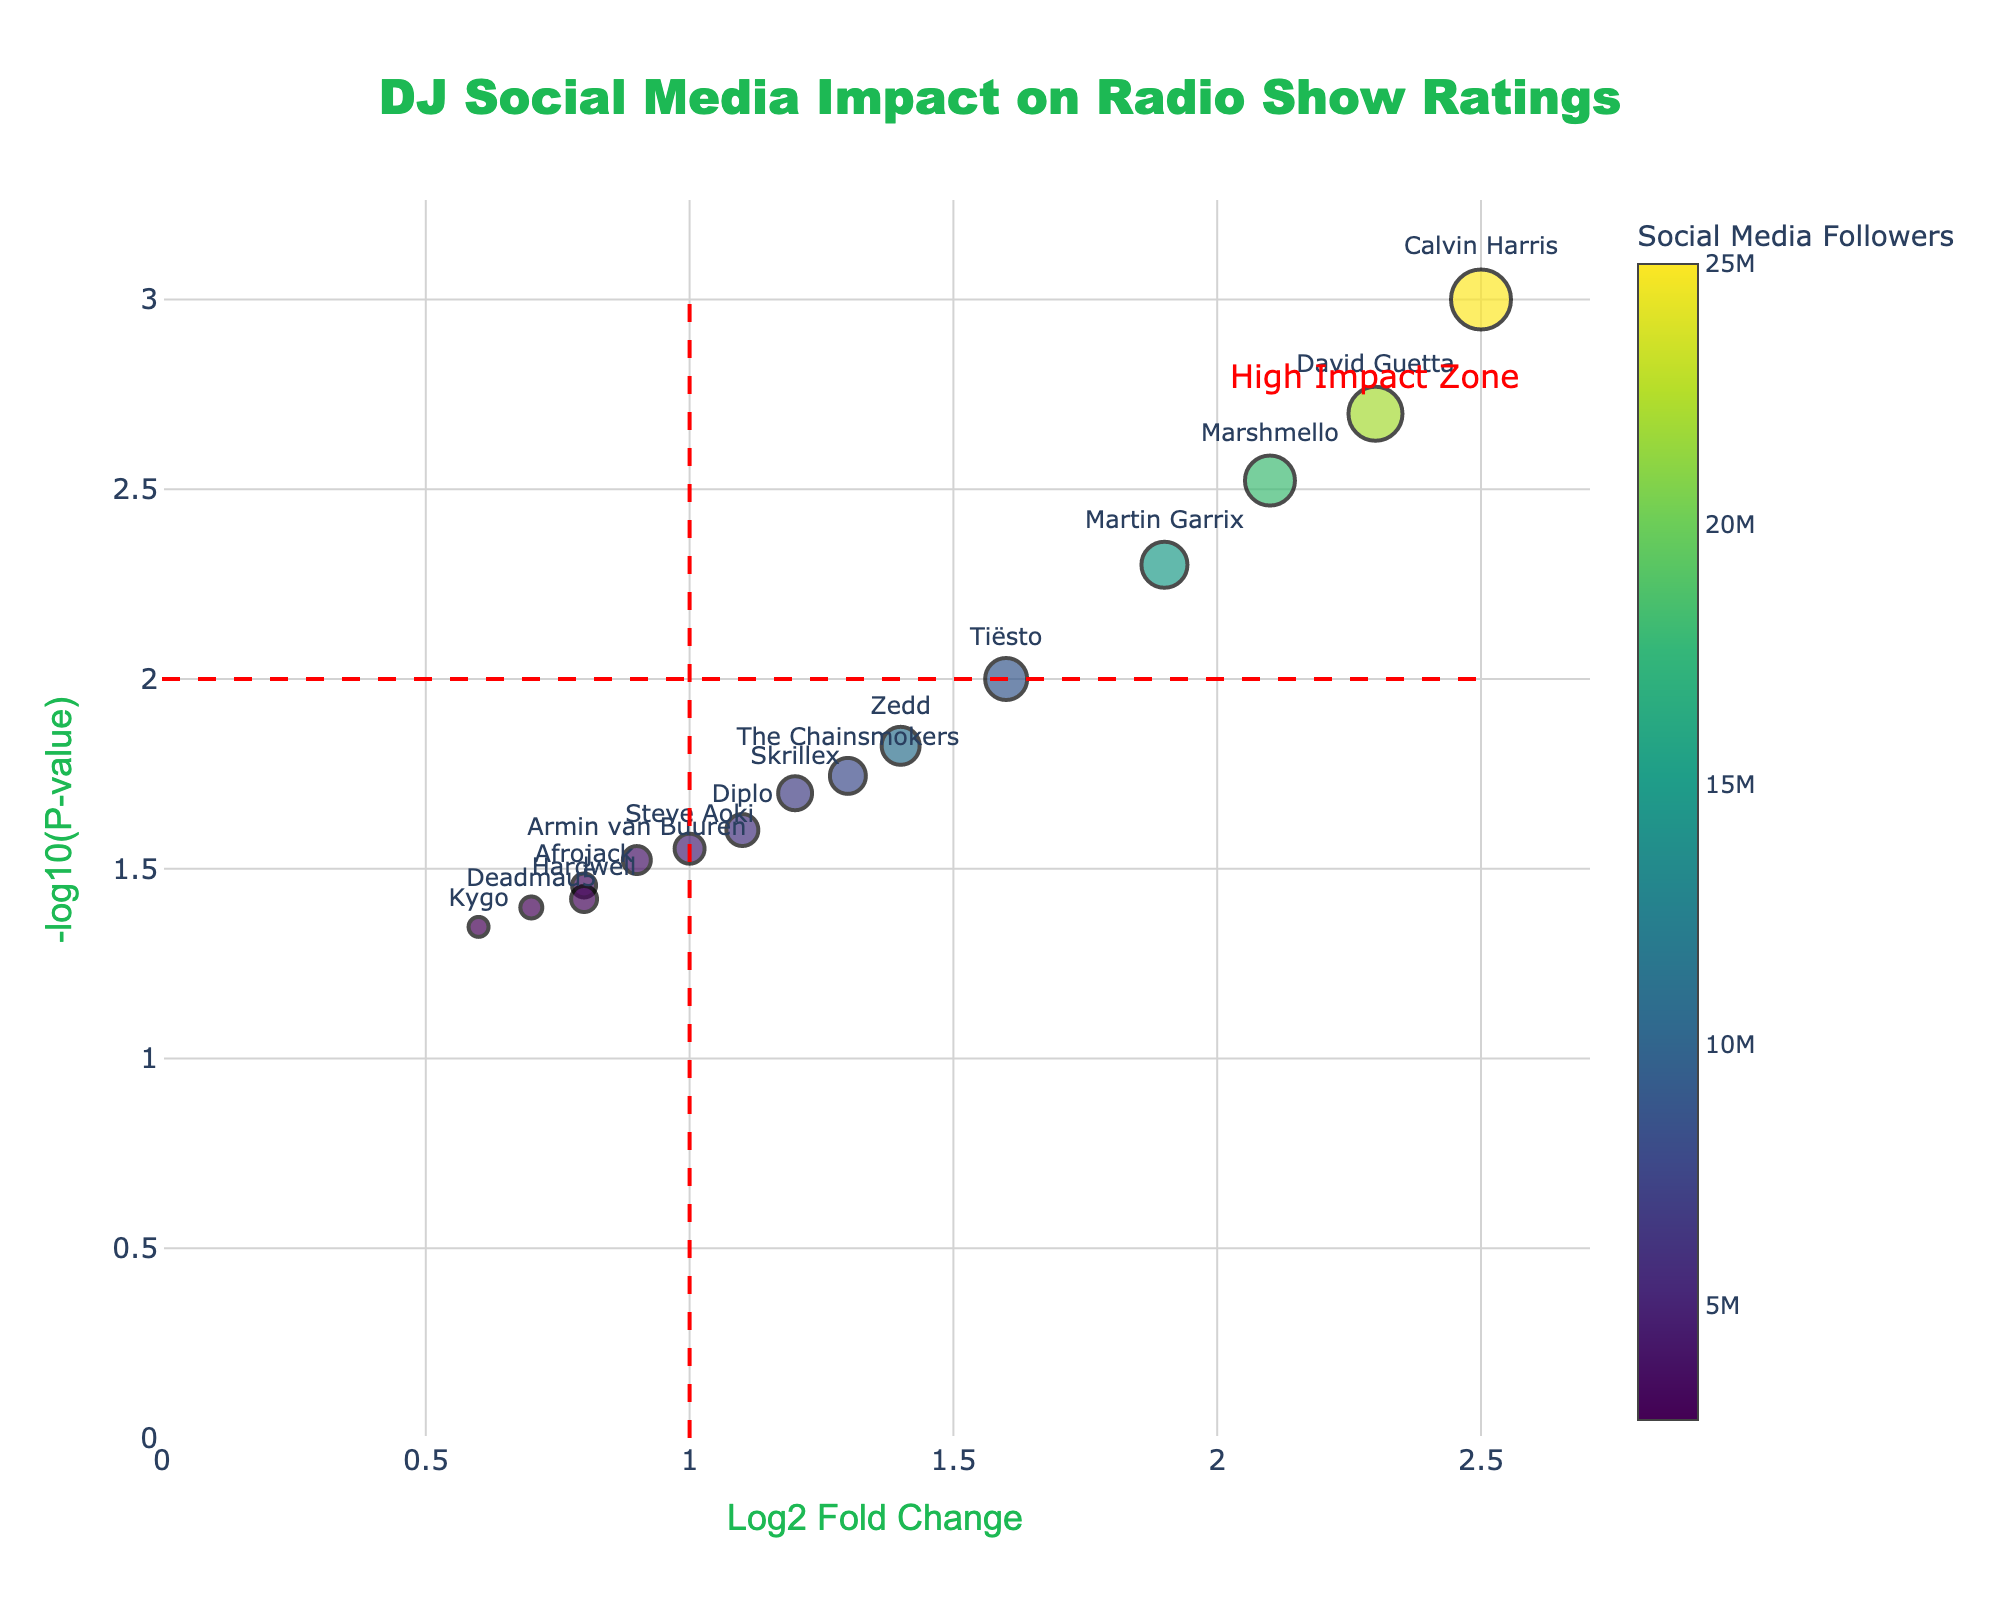How many DJs are displayed in the plot? To determine the number of DJs, count the number of markers or data points visible in the plot. Each marker represents a DJ.
Answer: 15 What is the title of the plot? The title can usually be found at the top of the plot. In this case, it explicitly mentions the plot's content.
Answer: DJ Social Media Impact on Radio Show Ratings Which DJ has the highest Log2 Fold Change (Log2FC)? Log2FC values are shown on the x-axis. By identifying the marker farthest to the right, you can determine the DJ with the highest Log2FC.
Answer: Calvin Harris How many DJs have a P-value less than 0.02? To find this, look for markers above the -log10(P-value) of -log10(0.02). Count these markers.
Answer: 6 Which DJ has the fewest social media followers, and what is their Radio Show Rating? To find the DJ with the fewest followers, look for the marker with the lowest color intensity or read the hover text for each DJ. Identify their corresponding Radio Show Rating from the hover text or marker size.
Answer: Deadmau5, 7.3 Which DJ is in the "High Impact Zone"? The "High Impact Zone" is marked by annotations or lines. Find the DJ within this region's boundaries, which is defined by a Log2FC greater than 2 and -log10(P-value) greater than 2.
Answer: Calvin Harris Compare the Radio Show Ratings between Marshmello and David Guetta. Who has a higher rating? Check the hover text or marker sizes for Marshmello and David Guetta, and compare their Radio Show Ratings.
Answer: Calvin Harris What’s the average Log2FC of DJs with a Radio Show Rating above 8.0? Identify the DJs with Radio Show Ratings above 8.0 from the hover text, sum their Log2FC values, and divide by the number of such DJs. The DJs are Calvin Harris, Marshmello, David Guetta, Martin Garrix, and The Chainsmokers. Their Log2FC values sum to 2.5 + 2.1 + 2.3 + 1.9 + 1.3 = 10.1. Dividing by 5 gives the average.
Answer: 2.02 Which DJ stands at the median position when sorted by Social Media Followers from highest to lowest? First, sort the DJs by Social Media Followers from highest to lowest. The median position will be the middle DJ. With 15 DJs, the median is the 8th DJ in the sorted list.
Answer: Tiësto What is the Log2 Fold Change (Log2FC) value for DJ Zedd? Find DJ Zedd's marker and hover over it to get the detailed hover text which includes the Log2FC value.
Answer: 1.4 